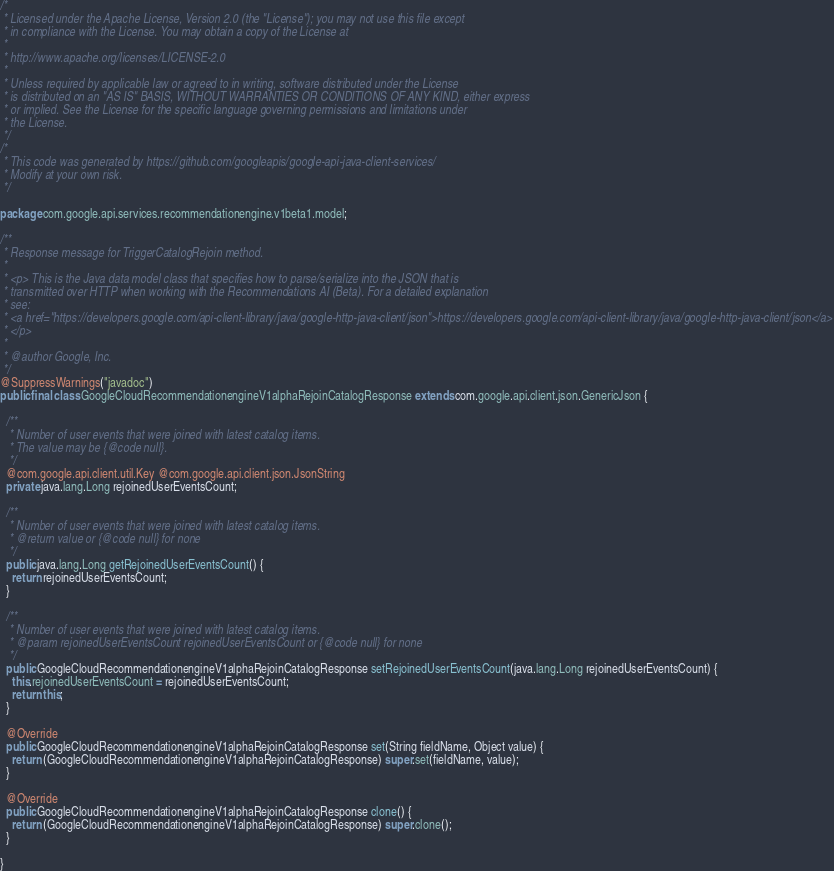Convert code to text. <code><loc_0><loc_0><loc_500><loc_500><_Java_>/*
 * Licensed under the Apache License, Version 2.0 (the "License"); you may not use this file except
 * in compliance with the License. You may obtain a copy of the License at
 *
 * http://www.apache.org/licenses/LICENSE-2.0
 *
 * Unless required by applicable law or agreed to in writing, software distributed under the License
 * is distributed on an "AS IS" BASIS, WITHOUT WARRANTIES OR CONDITIONS OF ANY KIND, either express
 * or implied. See the License for the specific language governing permissions and limitations under
 * the License.
 */
/*
 * This code was generated by https://github.com/googleapis/google-api-java-client-services/
 * Modify at your own risk.
 */

package com.google.api.services.recommendationengine.v1beta1.model;

/**
 * Response message for TriggerCatalogRejoin method.
 *
 * <p> This is the Java data model class that specifies how to parse/serialize into the JSON that is
 * transmitted over HTTP when working with the Recommendations AI (Beta). For a detailed explanation
 * see:
 * <a href="https://developers.google.com/api-client-library/java/google-http-java-client/json">https://developers.google.com/api-client-library/java/google-http-java-client/json</a>
 * </p>
 *
 * @author Google, Inc.
 */
@SuppressWarnings("javadoc")
public final class GoogleCloudRecommendationengineV1alphaRejoinCatalogResponse extends com.google.api.client.json.GenericJson {

  /**
   * Number of user events that were joined with latest catalog items.
   * The value may be {@code null}.
   */
  @com.google.api.client.util.Key @com.google.api.client.json.JsonString
  private java.lang.Long rejoinedUserEventsCount;

  /**
   * Number of user events that were joined with latest catalog items.
   * @return value or {@code null} for none
   */
  public java.lang.Long getRejoinedUserEventsCount() {
    return rejoinedUserEventsCount;
  }

  /**
   * Number of user events that were joined with latest catalog items.
   * @param rejoinedUserEventsCount rejoinedUserEventsCount or {@code null} for none
   */
  public GoogleCloudRecommendationengineV1alphaRejoinCatalogResponse setRejoinedUserEventsCount(java.lang.Long rejoinedUserEventsCount) {
    this.rejoinedUserEventsCount = rejoinedUserEventsCount;
    return this;
  }

  @Override
  public GoogleCloudRecommendationengineV1alphaRejoinCatalogResponse set(String fieldName, Object value) {
    return (GoogleCloudRecommendationengineV1alphaRejoinCatalogResponse) super.set(fieldName, value);
  }

  @Override
  public GoogleCloudRecommendationengineV1alphaRejoinCatalogResponse clone() {
    return (GoogleCloudRecommendationengineV1alphaRejoinCatalogResponse) super.clone();
  }

}
</code> 